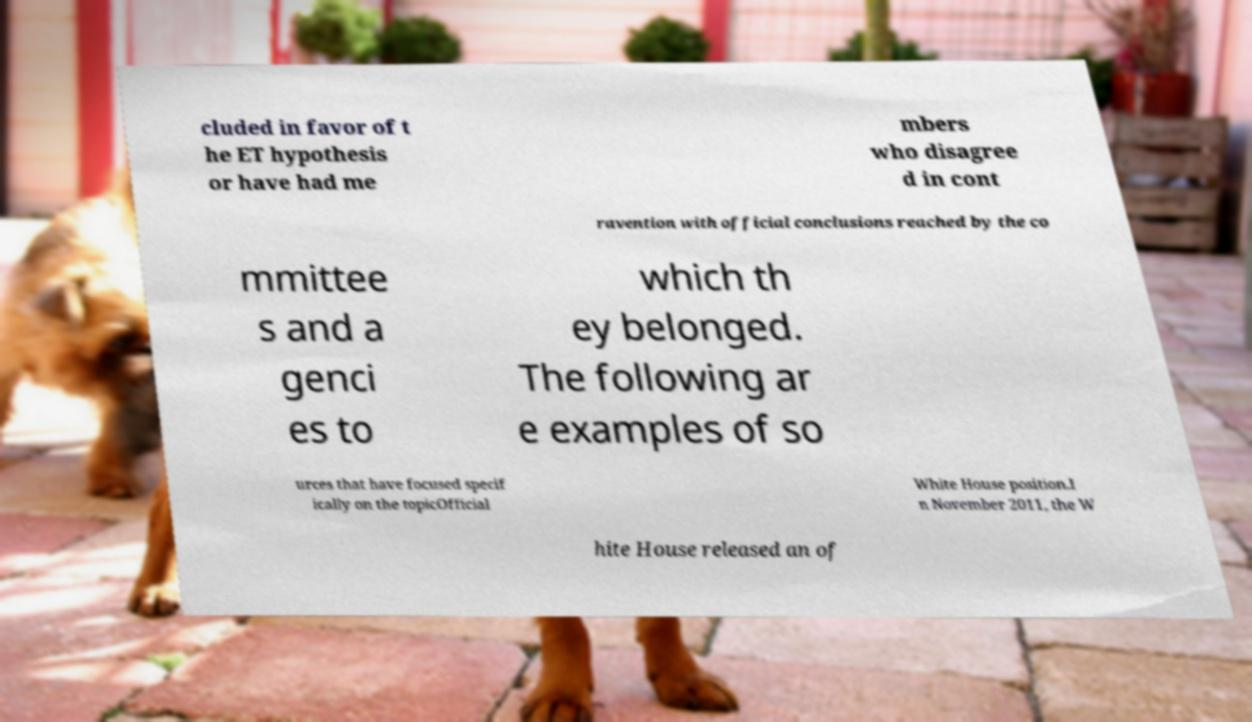Could you extract and type out the text from this image? cluded in favor of t he ET hypothesis or have had me mbers who disagree d in cont ravention with official conclusions reached by the co mmittee s and a genci es to which th ey belonged. The following ar e examples of so urces that have focused specif ically on the topicOfficial White House position.I n November 2011, the W hite House released an of 